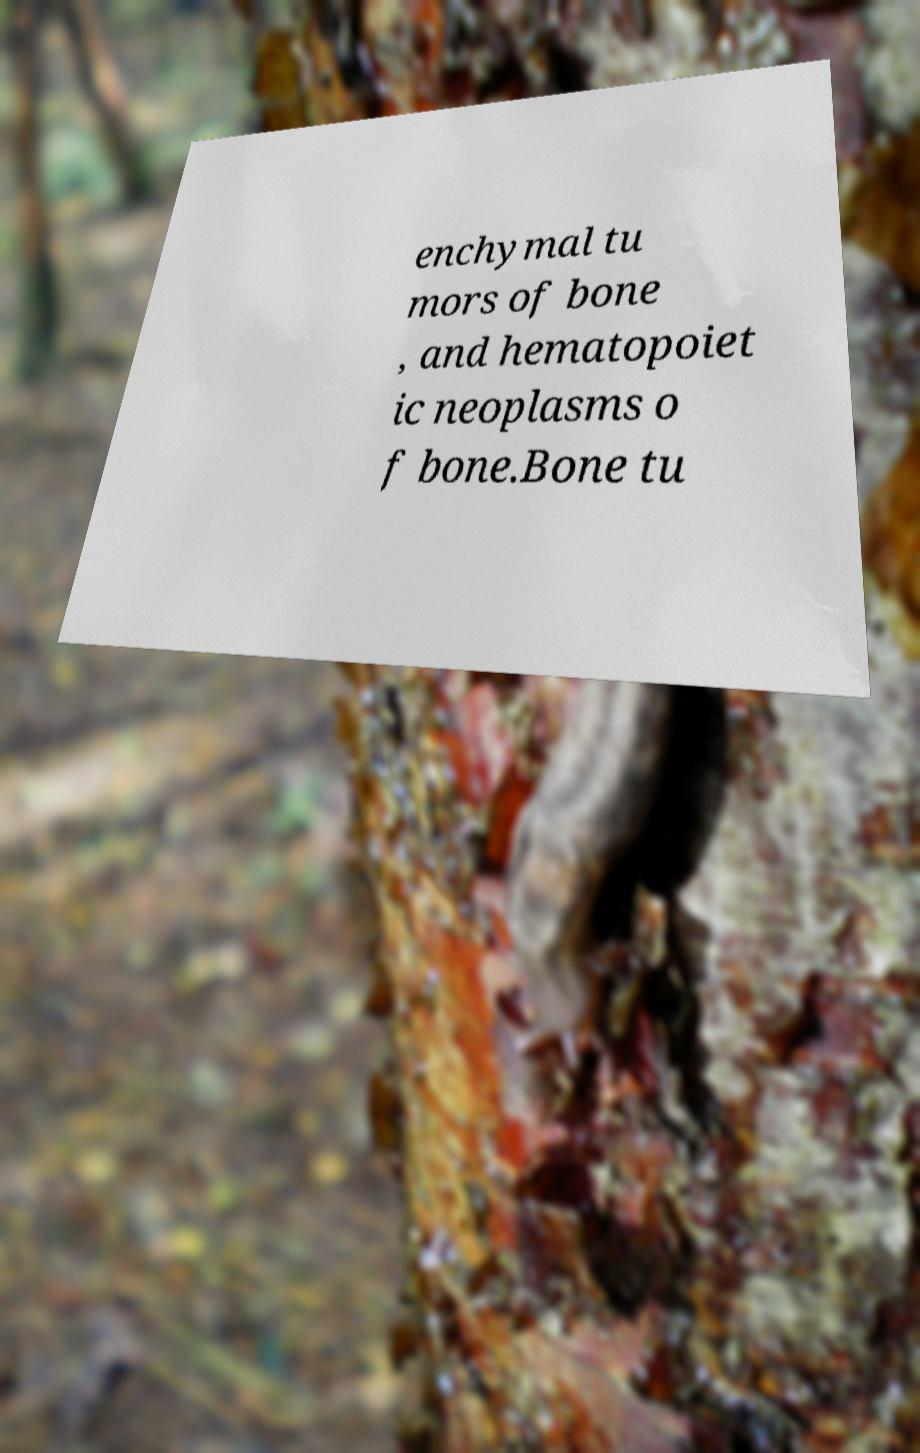I need the written content from this picture converted into text. Can you do that? enchymal tu mors of bone , and hematopoiet ic neoplasms o f bone.Bone tu 